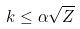<formula> <loc_0><loc_0><loc_500><loc_500>k \leq \alpha \sqrt { Z }</formula> 